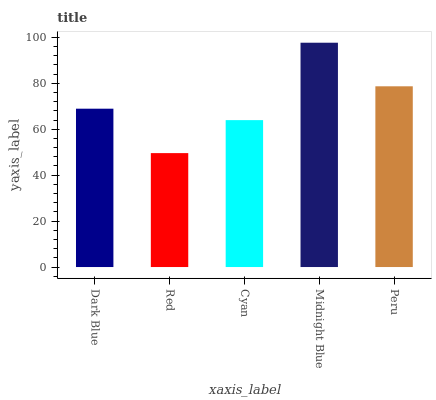Is Red the minimum?
Answer yes or no. Yes. Is Midnight Blue the maximum?
Answer yes or no. Yes. Is Cyan the minimum?
Answer yes or no. No. Is Cyan the maximum?
Answer yes or no. No. Is Cyan greater than Red?
Answer yes or no. Yes. Is Red less than Cyan?
Answer yes or no. Yes. Is Red greater than Cyan?
Answer yes or no. No. Is Cyan less than Red?
Answer yes or no. No. Is Dark Blue the high median?
Answer yes or no. Yes. Is Dark Blue the low median?
Answer yes or no. Yes. Is Red the high median?
Answer yes or no. No. Is Red the low median?
Answer yes or no. No. 